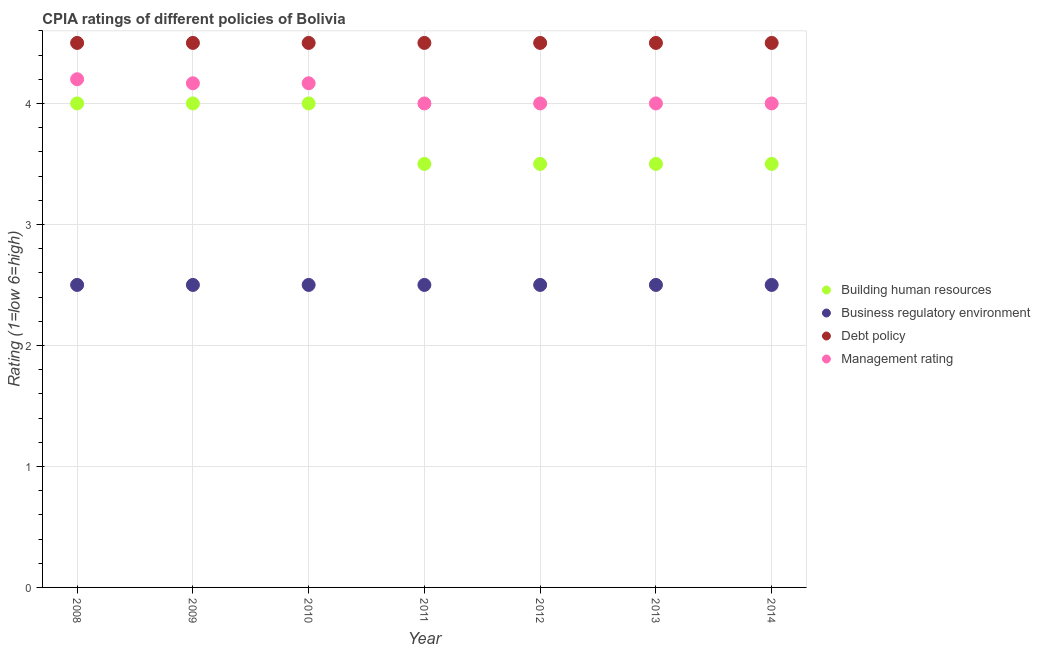Is the number of dotlines equal to the number of legend labels?
Provide a short and direct response. Yes. What is the cpia rating of building human resources in 2009?
Give a very brief answer. 4. In which year was the cpia rating of management maximum?
Your response must be concise. 2008. What is the difference between the cpia rating of building human resources in 2012 and that in 2013?
Make the answer very short. 0. What is the difference between the cpia rating of debt policy in 2013 and the cpia rating of business regulatory environment in 2008?
Your answer should be compact. 2. In the year 2011, what is the difference between the cpia rating of debt policy and cpia rating of business regulatory environment?
Make the answer very short. 2. Is the cpia rating of building human resources in 2010 less than that in 2011?
Provide a succinct answer. No. What is the difference between the highest and the second highest cpia rating of management?
Offer a very short reply. 0.03. Is the sum of the cpia rating of building human resources in 2008 and 2009 greater than the maximum cpia rating of management across all years?
Offer a terse response. Yes. Is it the case that in every year, the sum of the cpia rating of management and cpia rating of building human resources is greater than the sum of cpia rating of business regulatory environment and cpia rating of debt policy?
Your response must be concise. Yes. Does the cpia rating of management monotonically increase over the years?
Give a very brief answer. No. Is the cpia rating of debt policy strictly greater than the cpia rating of business regulatory environment over the years?
Your response must be concise. Yes. Is the cpia rating of building human resources strictly less than the cpia rating of management over the years?
Your answer should be very brief. Yes. How many dotlines are there?
Offer a terse response. 4. Does the graph contain any zero values?
Provide a short and direct response. No. Does the graph contain grids?
Keep it short and to the point. Yes. How are the legend labels stacked?
Keep it short and to the point. Vertical. What is the title of the graph?
Provide a short and direct response. CPIA ratings of different policies of Bolivia. Does "United States" appear as one of the legend labels in the graph?
Your answer should be very brief. No. What is the label or title of the Y-axis?
Your answer should be compact. Rating (1=low 6=high). What is the Rating (1=low 6=high) in Business regulatory environment in 2008?
Your answer should be compact. 2.5. What is the Rating (1=low 6=high) of Business regulatory environment in 2009?
Make the answer very short. 2.5. What is the Rating (1=low 6=high) in Management rating in 2009?
Your answer should be compact. 4.17. What is the Rating (1=low 6=high) of Building human resources in 2010?
Keep it short and to the point. 4. What is the Rating (1=low 6=high) of Business regulatory environment in 2010?
Your response must be concise. 2.5. What is the Rating (1=low 6=high) in Debt policy in 2010?
Your response must be concise. 4.5. What is the Rating (1=low 6=high) in Management rating in 2010?
Your response must be concise. 4.17. What is the Rating (1=low 6=high) in Business regulatory environment in 2011?
Provide a short and direct response. 2.5. What is the Rating (1=low 6=high) of Management rating in 2011?
Offer a very short reply. 4. What is the Rating (1=low 6=high) of Building human resources in 2012?
Ensure brevity in your answer.  3.5. What is the Rating (1=low 6=high) in Debt policy in 2012?
Offer a very short reply. 4.5. What is the Rating (1=low 6=high) in Debt policy in 2013?
Make the answer very short. 4.5. What is the Rating (1=low 6=high) of Management rating in 2013?
Your response must be concise. 4. What is the Rating (1=low 6=high) of Building human resources in 2014?
Your response must be concise. 3.5. What is the Rating (1=low 6=high) in Debt policy in 2014?
Your response must be concise. 4.5. What is the Rating (1=low 6=high) of Management rating in 2014?
Ensure brevity in your answer.  4. Across all years, what is the maximum Rating (1=low 6=high) of Business regulatory environment?
Keep it short and to the point. 2.5. Across all years, what is the maximum Rating (1=low 6=high) in Debt policy?
Provide a succinct answer. 4.5. Across all years, what is the minimum Rating (1=low 6=high) of Building human resources?
Offer a terse response. 3.5. Across all years, what is the minimum Rating (1=low 6=high) in Debt policy?
Offer a terse response. 4.5. Across all years, what is the minimum Rating (1=low 6=high) in Management rating?
Provide a short and direct response. 4. What is the total Rating (1=low 6=high) in Business regulatory environment in the graph?
Your answer should be very brief. 17.5. What is the total Rating (1=low 6=high) of Debt policy in the graph?
Give a very brief answer. 31.5. What is the total Rating (1=low 6=high) in Management rating in the graph?
Your answer should be compact. 28.53. What is the difference between the Rating (1=low 6=high) of Debt policy in 2008 and that in 2009?
Keep it short and to the point. 0. What is the difference between the Rating (1=low 6=high) in Building human resources in 2008 and that in 2010?
Ensure brevity in your answer.  0. What is the difference between the Rating (1=low 6=high) in Business regulatory environment in 2008 and that in 2012?
Give a very brief answer. 0. What is the difference between the Rating (1=low 6=high) of Debt policy in 2008 and that in 2012?
Provide a short and direct response. 0. What is the difference between the Rating (1=low 6=high) of Building human resources in 2008 and that in 2014?
Offer a very short reply. 0.5. What is the difference between the Rating (1=low 6=high) of Business regulatory environment in 2008 and that in 2014?
Offer a very short reply. 0. What is the difference between the Rating (1=low 6=high) of Business regulatory environment in 2009 and that in 2011?
Your answer should be compact. 0. What is the difference between the Rating (1=low 6=high) of Management rating in 2009 and that in 2011?
Your response must be concise. 0.17. What is the difference between the Rating (1=low 6=high) of Debt policy in 2009 and that in 2013?
Provide a succinct answer. 0. What is the difference between the Rating (1=low 6=high) in Management rating in 2009 and that in 2013?
Give a very brief answer. 0.17. What is the difference between the Rating (1=low 6=high) in Building human resources in 2009 and that in 2014?
Provide a short and direct response. 0.5. What is the difference between the Rating (1=low 6=high) in Building human resources in 2010 and that in 2011?
Your answer should be compact. 0.5. What is the difference between the Rating (1=low 6=high) of Business regulatory environment in 2010 and that in 2012?
Your answer should be compact. 0. What is the difference between the Rating (1=low 6=high) of Debt policy in 2010 and that in 2012?
Ensure brevity in your answer.  0. What is the difference between the Rating (1=low 6=high) in Management rating in 2010 and that in 2012?
Your answer should be very brief. 0.17. What is the difference between the Rating (1=low 6=high) of Building human resources in 2010 and that in 2013?
Your answer should be very brief. 0.5. What is the difference between the Rating (1=low 6=high) in Business regulatory environment in 2010 and that in 2013?
Provide a succinct answer. 0. What is the difference between the Rating (1=low 6=high) of Management rating in 2010 and that in 2013?
Provide a short and direct response. 0.17. What is the difference between the Rating (1=low 6=high) of Building human resources in 2010 and that in 2014?
Offer a very short reply. 0.5. What is the difference between the Rating (1=low 6=high) in Debt policy in 2010 and that in 2014?
Your answer should be compact. 0. What is the difference between the Rating (1=low 6=high) in Management rating in 2010 and that in 2014?
Keep it short and to the point. 0.17. What is the difference between the Rating (1=low 6=high) of Building human resources in 2011 and that in 2012?
Your answer should be very brief. 0. What is the difference between the Rating (1=low 6=high) in Business regulatory environment in 2011 and that in 2012?
Give a very brief answer. 0. What is the difference between the Rating (1=low 6=high) in Debt policy in 2011 and that in 2012?
Your response must be concise. 0. What is the difference between the Rating (1=low 6=high) in Management rating in 2011 and that in 2012?
Your answer should be very brief. 0. What is the difference between the Rating (1=low 6=high) in Building human resources in 2011 and that in 2013?
Your answer should be compact. 0. What is the difference between the Rating (1=low 6=high) of Business regulatory environment in 2011 and that in 2013?
Keep it short and to the point. 0. What is the difference between the Rating (1=low 6=high) of Debt policy in 2011 and that in 2013?
Keep it short and to the point. 0. What is the difference between the Rating (1=low 6=high) of Management rating in 2011 and that in 2013?
Ensure brevity in your answer.  0. What is the difference between the Rating (1=low 6=high) in Business regulatory environment in 2011 and that in 2014?
Offer a very short reply. 0. What is the difference between the Rating (1=low 6=high) in Building human resources in 2012 and that in 2013?
Give a very brief answer. 0. What is the difference between the Rating (1=low 6=high) in Management rating in 2012 and that in 2013?
Provide a short and direct response. 0. What is the difference between the Rating (1=low 6=high) in Business regulatory environment in 2012 and that in 2014?
Offer a terse response. 0. What is the difference between the Rating (1=low 6=high) of Debt policy in 2012 and that in 2014?
Ensure brevity in your answer.  0. What is the difference between the Rating (1=low 6=high) of Management rating in 2012 and that in 2014?
Make the answer very short. 0. What is the difference between the Rating (1=low 6=high) of Building human resources in 2008 and the Rating (1=low 6=high) of Business regulatory environment in 2009?
Your response must be concise. 1.5. What is the difference between the Rating (1=low 6=high) in Building human resources in 2008 and the Rating (1=low 6=high) in Debt policy in 2009?
Provide a short and direct response. -0.5. What is the difference between the Rating (1=low 6=high) in Building human resources in 2008 and the Rating (1=low 6=high) in Management rating in 2009?
Offer a very short reply. -0.17. What is the difference between the Rating (1=low 6=high) in Business regulatory environment in 2008 and the Rating (1=low 6=high) in Management rating in 2009?
Give a very brief answer. -1.67. What is the difference between the Rating (1=low 6=high) in Building human resources in 2008 and the Rating (1=low 6=high) in Business regulatory environment in 2010?
Offer a terse response. 1.5. What is the difference between the Rating (1=low 6=high) of Building human resources in 2008 and the Rating (1=low 6=high) of Debt policy in 2010?
Your answer should be very brief. -0.5. What is the difference between the Rating (1=low 6=high) in Business regulatory environment in 2008 and the Rating (1=low 6=high) in Management rating in 2010?
Give a very brief answer. -1.67. What is the difference between the Rating (1=low 6=high) of Debt policy in 2008 and the Rating (1=low 6=high) of Management rating in 2011?
Provide a succinct answer. 0.5. What is the difference between the Rating (1=low 6=high) in Building human resources in 2008 and the Rating (1=low 6=high) in Debt policy in 2012?
Offer a very short reply. -0.5. What is the difference between the Rating (1=low 6=high) in Building human resources in 2008 and the Rating (1=low 6=high) in Management rating in 2012?
Your answer should be very brief. 0. What is the difference between the Rating (1=low 6=high) in Business regulatory environment in 2008 and the Rating (1=low 6=high) in Management rating in 2012?
Offer a terse response. -1.5. What is the difference between the Rating (1=low 6=high) of Debt policy in 2008 and the Rating (1=low 6=high) of Management rating in 2012?
Offer a terse response. 0.5. What is the difference between the Rating (1=low 6=high) of Building human resources in 2008 and the Rating (1=low 6=high) of Business regulatory environment in 2013?
Provide a succinct answer. 1.5. What is the difference between the Rating (1=low 6=high) of Building human resources in 2008 and the Rating (1=low 6=high) of Debt policy in 2013?
Offer a very short reply. -0.5. What is the difference between the Rating (1=low 6=high) in Building human resources in 2008 and the Rating (1=low 6=high) in Management rating in 2013?
Keep it short and to the point. 0. What is the difference between the Rating (1=low 6=high) in Business regulatory environment in 2008 and the Rating (1=low 6=high) in Debt policy in 2013?
Provide a succinct answer. -2. What is the difference between the Rating (1=low 6=high) of Business regulatory environment in 2008 and the Rating (1=low 6=high) of Management rating in 2013?
Your answer should be very brief. -1.5. What is the difference between the Rating (1=low 6=high) of Debt policy in 2008 and the Rating (1=low 6=high) of Management rating in 2013?
Make the answer very short. 0.5. What is the difference between the Rating (1=low 6=high) of Building human resources in 2008 and the Rating (1=low 6=high) of Business regulatory environment in 2014?
Your answer should be very brief. 1.5. What is the difference between the Rating (1=low 6=high) in Building human resources in 2008 and the Rating (1=low 6=high) in Management rating in 2014?
Make the answer very short. 0. What is the difference between the Rating (1=low 6=high) in Business regulatory environment in 2008 and the Rating (1=low 6=high) in Debt policy in 2014?
Your response must be concise. -2. What is the difference between the Rating (1=low 6=high) of Debt policy in 2008 and the Rating (1=low 6=high) of Management rating in 2014?
Your answer should be very brief. 0.5. What is the difference between the Rating (1=low 6=high) in Building human resources in 2009 and the Rating (1=low 6=high) in Business regulatory environment in 2010?
Offer a very short reply. 1.5. What is the difference between the Rating (1=low 6=high) of Building human resources in 2009 and the Rating (1=low 6=high) of Management rating in 2010?
Make the answer very short. -0.17. What is the difference between the Rating (1=low 6=high) of Business regulatory environment in 2009 and the Rating (1=low 6=high) of Management rating in 2010?
Make the answer very short. -1.67. What is the difference between the Rating (1=low 6=high) in Debt policy in 2009 and the Rating (1=low 6=high) in Management rating in 2010?
Offer a terse response. 0.33. What is the difference between the Rating (1=low 6=high) of Building human resources in 2009 and the Rating (1=low 6=high) of Debt policy in 2011?
Make the answer very short. -0.5. What is the difference between the Rating (1=low 6=high) of Business regulatory environment in 2009 and the Rating (1=low 6=high) of Debt policy in 2011?
Give a very brief answer. -2. What is the difference between the Rating (1=low 6=high) of Building human resources in 2009 and the Rating (1=low 6=high) of Business regulatory environment in 2012?
Offer a very short reply. 1.5. What is the difference between the Rating (1=low 6=high) in Building human resources in 2009 and the Rating (1=low 6=high) in Management rating in 2012?
Your answer should be very brief. 0. What is the difference between the Rating (1=low 6=high) in Business regulatory environment in 2009 and the Rating (1=low 6=high) in Management rating in 2012?
Give a very brief answer. -1.5. What is the difference between the Rating (1=low 6=high) of Business regulatory environment in 2009 and the Rating (1=low 6=high) of Debt policy in 2013?
Your answer should be very brief. -2. What is the difference between the Rating (1=low 6=high) in Business regulatory environment in 2009 and the Rating (1=low 6=high) in Management rating in 2013?
Your response must be concise. -1.5. What is the difference between the Rating (1=low 6=high) in Debt policy in 2009 and the Rating (1=low 6=high) in Management rating in 2013?
Provide a succinct answer. 0.5. What is the difference between the Rating (1=low 6=high) of Building human resources in 2009 and the Rating (1=low 6=high) of Management rating in 2014?
Your answer should be compact. 0. What is the difference between the Rating (1=low 6=high) in Business regulatory environment in 2009 and the Rating (1=low 6=high) in Debt policy in 2014?
Give a very brief answer. -2. What is the difference between the Rating (1=low 6=high) of Building human resources in 2010 and the Rating (1=low 6=high) of Debt policy in 2011?
Your answer should be very brief. -0.5. What is the difference between the Rating (1=low 6=high) of Building human resources in 2010 and the Rating (1=low 6=high) of Management rating in 2011?
Give a very brief answer. 0. What is the difference between the Rating (1=low 6=high) of Business regulatory environment in 2010 and the Rating (1=low 6=high) of Debt policy in 2011?
Your answer should be compact. -2. What is the difference between the Rating (1=low 6=high) in Business regulatory environment in 2010 and the Rating (1=low 6=high) in Management rating in 2011?
Give a very brief answer. -1.5. What is the difference between the Rating (1=low 6=high) in Building human resources in 2010 and the Rating (1=low 6=high) in Business regulatory environment in 2012?
Make the answer very short. 1.5. What is the difference between the Rating (1=low 6=high) in Building human resources in 2010 and the Rating (1=low 6=high) in Management rating in 2012?
Offer a very short reply. 0. What is the difference between the Rating (1=low 6=high) in Business regulatory environment in 2010 and the Rating (1=low 6=high) in Debt policy in 2012?
Keep it short and to the point. -2. What is the difference between the Rating (1=low 6=high) of Debt policy in 2010 and the Rating (1=low 6=high) of Management rating in 2012?
Make the answer very short. 0.5. What is the difference between the Rating (1=low 6=high) of Building human resources in 2010 and the Rating (1=low 6=high) of Debt policy in 2013?
Your answer should be compact. -0.5. What is the difference between the Rating (1=low 6=high) of Building human resources in 2010 and the Rating (1=low 6=high) of Management rating in 2013?
Provide a short and direct response. 0. What is the difference between the Rating (1=low 6=high) of Building human resources in 2010 and the Rating (1=low 6=high) of Business regulatory environment in 2014?
Make the answer very short. 1.5. What is the difference between the Rating (1=low 6=high) in Building human resources in 2011 and the Rating (1=low 6=high) in Business regulatory environment in 2012?
Keep it short and to the point. 1. What is the difference between the Rating (1=low 6=high) in Building human resources in 2011 and the Rating (1=low 6=high) in Debt policy in 2012?
Your response must be concise. -1. What is the difference between the Rating (1=low 6=high) in Business regulatory environment in 2011 and the Rating (1=low 6=high) in Debt policy in 2012?
Provide a succinct answer. -2. What is the difference between the Rating (1=low 6=high) of Building human resources in 2011 and the Rating (1=low 6=high) of Management rating in 2013?
Provide a short and direct response. -0.5. What is the difference between the Rating (1=low 6=high) in Business regulatory environment in 2011 and the Rating (1=low 6=high) in Debt policy in 2013?
Ensure brevity in your answer.  -2. What is the difference between the Rating (1=low 6=high) of Business regulatory environment in 2011 and the Rating (1=low 6=high) of Management rating in 2013?
Offer a terse response. -1.5. What is the difference between the Rating (1=low 6=high) of Debt policy in 2011 and the Rating (1=low 6=high) of Management rating in 2013?
Keep it short and to the point. 0.5. What is the difference between the Rating (1=low 6=high) of Building human resources in 2011 and the Rating (1=low 6=high) of Business regulatory environment in 2014?
Your response must be concise. 1. What is the difference between the Rating (1=low 6=high) of Building human resources in 2011 and the Rating (1=low 6=high) of Management rating in 2014?
Offer a very short reply. -0.5. What is the difference between the Rating (1=low 6=high) in Business regulatory environment in 2011 and the Rating (1=low 6=high) in Debt policy in 2014?
Give a very brief answer. -2. What is the difference between the Rating (1=low 6=high) of Building human resources in 2012 and the Rating (1=low 6=high) of Business regulatory environment in 2013?
Provide a succinct answer. 1. What is the difference between the Rating (1=low 6=high) of Building human resources in 2012 and the Rating (1=low 6=high) of Debt policy in 2013?
Ensure brevity in your answer.  -1. What is the difference between the Rating (1=low 6=high) of Building human resources in 2012 and the Rating (1=low 6=high) of Management rating in 2013?
Provide a short and direct response. -0.5. What is the difference between the Rating (1=low 6=high) of Business regulatory environment in 2012 and the Rating (1=low 6=high) of Debt policy in 2013?
Your answer should be very brief. -2. What is the difference between the Rating (1=low 6=high) in Business regulatory environment in 2012 and the Rating (1=low 6=high) in Management rating in 2013?
Keep it short and to the point. -1.5. What is the difference between the Rating (1=low 6=high) in Debt policy in 2012 and the Rating (1=low 6=high) in Management rating in 2013?
Your answer should be very brief. 0.5. What is the difference between the Rating (1=low 6=high) in Building human resources in 2012 and the Rating (1=low 6=high) in Business regulatory environment in 2014?
Make the answer very short. 1. What is the difference between the Rating (1=low 6=high) of Business regulatory environment in 2012 and the Rating (1=low 6=high) of Management rating in 2014?
Provide a short and direct response. -1.5. What is the difference between the Rating (1=low 6=high) in Debt policy in 2012 and the Rating (1=low 6=high) in Management rating in 2014?
Provide a short and direct response. 0.5. What is the difference between the Rating (1=low 6=high) of Building human resources in 2013 and the Rating (1=low 6=high) of Management rating in 2014?
Your response must be concise. -0.5. What is the difference between the Rating (1=low 6=high) in Debt policy in 2013 and the Rating (1=low 6=high) in Management rating in 2014?
Make the answer very short. 0.5. What is the average Rating (1=low 6=high) in Building human resources per year?
Give a very brief answer. 3.71. What is the average Rating (1=low 6=high) of Debt policy per year?
Make the answer very short. 4.5. What is the average Rating (1=low 6=high) in Management rating per year?
Offer a terse response. 4.08. In the year 2008, what is the difference between the Rating (1=low 6=high) of Building human resources and Rating (1=low 6=high) of Management rating?
Your response must be concise. -0.2. In the year 2008, what is the difference between the Rating (1=low 6=high) of Business regulatory environment and Rating (1=low 6=high) of Debt policy?
Provide a short and direct response. -2. In the year 2008, what is the difference between the Rating (1=low 6=high) of Business regulatory environment and Rating (1=low 6=high) of Management rating?
Make the answer very short. -1.7. In the year 2009, what is the difference between the Rating (1=low 6=high) of Building human resources and Rating (1=low 6=high) of Business regulatory environment?
Your answer should be very brief. 1.5. In the year 2009, what is the difference between the Rating (1=low 6=high) of Building human resources and Rating (1=low 6=high) of Management rating?
Make the answer very short. -0.17. In the year 2009, what is the difference between the Rating (1=low 6=high) of Business regulatory environment and Rating (1=low 6=high) of Debt policy?
Provide a short and direct response. -2. In the year 2009, what is the difference between the Rating (1=low 6=high) of Business regulatory environment and Rating (1=low 6=high) of Management rating?
Your response must be concise. -1.67. In the year 2010, what is the difference between the Rating (1=low 6=high) of Building human resources and Rating (1=low 6=high) of Business regulatory environment?
Give a very brief answer. 1.5. In the year 2010, what is the difference between the Rating (1=low 6=high) in Building human resources and Rating (1=low 6=high) in Debt policy?
Your response must be concise. -0.5. In the year 2010, what is the difference between the Rating (1=low 6=high) in Building human resources and Rating (1=low 6=high) in Management rating?
Your answer should be compact. -0.17. In the year 2010, what is the difference between the Rating (1=low 6=high) of Business regulatory environment and Rating (1=low 6=high) of Management rating?
Provide a short and direct response. -1.67. In the year 2010, what is the difference between the Rating (1=low 6=high) in Debt policy and Rating (1=low 6=high) in Management rating?
Your answer should be compact. 0.33. In the year 2011, what is the difference between the Rating (1=low 6=high) in Building human resources and Rating (1=low 6=high) in Debt policy?
Provide a succinct answer. -1. In the year 2011, what is the difference between the Rating (1=low 6=high) of Building human resources and Rating (1=low 6=high) of Management rating?
Offer a very short reply. -0.5. In the year 2011, what is the difference between the Rating (1=low 6=high) in Business regulatory environment and Rating (1=low 6=high) in Debt policy?
Provide a succinct answer. -2. In the year 2011, what is the difference between the Rating (1=low 6=high) of Business regulatory environment and Rating (1=low 6=high) of Management rating?
Offer a very short reply. -1.5. In the year 2011, what is the difference between the Rating (1=low 6=high) of Debt policy and Rating (1=low 6=high) of Management rating?
Offer a terse response. 0.5. In the year 2012, what is the difference between the Rating (1=low 6=high) of Building human resources and Rating (1=low 6=high) of Business regulatory environment?
Offer a very short reply. 1. In the year 2012, what is the difference between the Rating (1=low 6=high) of Building human resources and Rating (1=low 6=high) of Debt policy?
Make the answer very short. -1. In the year 2012, what is the difference between the Rating (1=low 6=high) of Building human resources and Rating (1=low 6=high) of Management rating?
Your response must be concise. -0.5. In the year 2012, what is the difference between the Rating (1=low 6=high) of Business regulatory environment and Rating (1=low 6=high) of Debt policy?
Give a very brief answer. -2. In the year 2013, what is the difference between the Rating (1=low 6=high) in Building human resources and Rating (1=low 6=high) in Business regulatory environment?
Ensure brevity in your answer.  1. In the year 2013, what is the difference between the Rating (1=low 6=high) of Building human resources and Rating (1=low 6=high) of Management rating?
Offer a terse response. -0.5. In the year 2013, what is the difference between the Rating (1=low 6=high) in Business regulatory environment and Rating (1=low 6=high) in Debt policy?
Your answer should be very brief. -2. In the year 2013, what is the difference between the Rating (1=low 6=high) in Business regulatory environment and Rating (1=low 6=high) in Management rating?
Keep it short and to the point. -1.5. In the year 2014, what is the difference between the Rating (1=low 6=high) of Building human resources and Rating (1=low 6=high) of Business regulatory environment?
Your answer should be very brief. 1. In the year 2014, what is the difference between the Rating (1=low 6=high) in Building human resources and Rating (1=low 6=high) in Debt policy?
Make the answer very short. -1. In the year 2014, what is the difference between the Rating (1=low 6=high) in Business regulatory environment and Rating (1=low 6=high) in Debt policy?
Provide a short and direct response. -2. In the year 2014, what is the difference between the Rating (1=low 6=high) in Business regulatory environment and Rating (1=low 6=high) in Management rating?
Make the answer very short. -1.5. In the year 2014, what is the difference between the Rating (1=low 6=high) of Debt policy and Rating (1=low 6=high) of Management rating?
Ensure brevity in your answer.  0.5. What is the ratio of the Rating (1=low 6=high) of Building human resources in 2008 to that in 2009?
Your response must be concise. 1. What is the ratio of the Rating (1=low 6=high) of Business regulatory environment in 2008 to that in 2009?
Make the answer very short. 1. What is the ratio of the Rating (1=low 6=high) of Building human resources in 2008 to that in 2010?
Keep it short and to the point. 1. What is the ratio of the Rating (1=low 6=high) of Debt policy in 2008 to that in 2010?
Give a very brief answer. 1. What is the ratio of the Rating (1=low 6=high) in Management rating in 2008 to that in 2010?
Your answer should be compact. 1.01. What is the ratio of the Rating (1=low 6=high) of Building human resources in 2008 to that in 2011?
Your answer should be very brief. 1.14. What is the ratio of the Rating (1=low 6=high) of Business regulatory environment in 2008 to that in 2011?
Keep it short and to the point. 1. What is the ratio of the Rating (1=low 6=high) in Debt policy in 2008 to that in 2011?
Keep it short and to the point. 1. What is the ratio of the Rating (1=low 6=high) in Building human resources in 2008 to that in 2012?
Your response must be concise. 1.14. What is the ratio of the Rating (1=low 6=high) of Business regulatory environment in 2008 to that in 2012?
Give a very brief answer. 1. What is the ratio of the Rating (1=low 6=high) of Debt policy in 2008 to that in 2012?
Your response must be concise. 1. What is the ratio of the Rating (1=low 6=high) in Management rating in 2008 to that in 2012?
Your answer should be very brief. 1.05. What is the ratio of the Rating (1=low 6=high) of Building human resources in 2008 to that in 2013?
Your answer should be very brief. 1.14. What is the ratio of the Rating (1=low 6=high) of Business regulatory environment in 2008 to that in 2013?
Give a very brief answer. 1. What is the ratio of the Rating (1=low 6=high) of Building human resources in 2008 to that in 2014?
Ensure brevity in your answer.  1.14. What is the ratio of the Rating (1=low 6=high) in Business regulatory environment in 2008 to that in 2014?
Offer a terse response. 1. What is the ratio of the Rating (1=low 6=high) in Debt policy in 2008 to that in 2014?
Keep it short and to the point. 1. What is the ratio of the Rating (1=low 6=high) of Management rating in 2008 to that in 2014?
Give a very brief answer. 1.05. What is the ratio of the Rating (1=low 6=high) of Building human resources in 2009 to that in 2010?
Give a very brief answer. 1. What is the ratio of the Rating (1=low 6=high) of Business regulatory environment in 2009 to that in 2010?
Ensure brevity in your answer.  1. What is the ratio of the Rating (1=low 6=high) of Debt policy in 2009 to that in 2010?
Your response must be concise. 1. What is the ratio of the Rating (1=low 6=high) of Building human resources in 2009 to that in 2011?
Keep it short and to the point. 1.14. What is the ratio of the Rating (1=low 6=high) of Management rating in 2009 to that in 2011?
Provide a short and direct response. 1.04. What is the ratio of the Rating (1=low 6=high) of Debt policy in 2009 to that in 2012?
Ensure brevity in your answer.  1. What is the ratio of the Rating (1=low 6=high) of Management rating in 2009 to that in 2012?
Offer a very short reply. 1.04. What is the ratio of the Rating (1=low 6=high) in Debt policy in 2009 to that in 2013?
Provide a short and direct response. 1. What is the ratio of the Rating (1=low 6=high) of Management rating in 2009 to that in 2013?
Provide a short and direct response. 1.04. What is the ratio of the Rating (1=low 6=high) of Building human resources in 2009 to that in 2014?
Keep it short and to the point. 1.14. What is the ratio of the Rating (1=low 6=high) in Business regulatory environment in 2009 to that in 2014?
Provide a short and direct response. 1. What is the ratio of the Rating (1=low 6=high) of Debt policy in 2009 to that in 2014?
Your answer should be compact. 1. What is the ratio of the Rating (1=low 6=high) of Management rating in 2009 to that in 2014?
Make the answer very short. 1.04. What is the ratio of the Rating (1=low 6=high) in Business regulatory environment in 2010 to that in 2011?
Your answer should be very brief. 1. What is the ratio of the Rating (1=low 6=high) in Management rating in 2010 to that in 2011?
Provide a short and direct response. 1.04. What is the ratio of the Rating (1=low 6=high) in Building human resources in 2010 to that in 2012?
Offer a very short reply. 1.14. What is the ratio of the Rating (1=low 6=high) in Business regulatory environment in 2010 to that in 2012?
Your response must be concise. 1. What is the ratio of the Rating (1=low 6=high) in Debt policy in 2010 to that in 2012?
Keep it short and to the point. 1. What is the ratio of the Rating (1=low 6=high) in Management rating in 2010 to that in 2012?
Provide a short and direct response. 1.04. What is the ratio of the Rating (1=low 6=high) of Building human resources in 2010 to that in 2013?
Give a very brief answer. 1.14. What is the ratio of the Rating (1=low 6=high) of Business regulatory environment in 2010 to that in 2013?
Give a very brief answer. 1. What is the ratio of the Rating (1=low 6=high) of Management rating in 2010 to that in 2013?
Make the answer very short. 1.04. What is the ratio of the Rating (1=low 6=high) of Business regulatory environment in 2010 to that in 2014?
Your answer should be very brief. 1. What is the ratio of the Rating (1=low 6=high) in Debt policy in 2010 to that in 2014?
Offer a very short reply. 1. What is the ratio of the Rating (1=low 6=high) in Management rating in 2010 to that in 2014?
Ensure brevity in your answer.  1.04. What is the ratio of the Rating (1=low 6=high) of Building human resources in 2011 to that in 2012?
Your answer should be very brief. 1. What is the ratio of the Rating (1=low 6=high) in Business regulatory environment in 2011 to that in 2012?
Keep it short and to the point. 1. What is the ratio of the Rating (1=low 6=high) in Building human resources in 2011 to that in 2013?
Offer a very short reply. 1. What is the ratio of the Rating (1=low 6=high) of Debt policy in 2011 to that in 2013?
Your answer should be very brief. 1. What is the ratio of the Rating (1=low 6=high) of Management rating in 2011 to that in 2013?
Keep it short and to the point. 1. What is the ratio of the Rating (1=low 6=high) of Debt policy in 2011 to that in 2014?
Provide a short and direct response. 1. What is the ratio of the Rating (1=low 6=high) in Debt policy in 2012 to that in 2013?
Provide a succinct answer. 1. What is the ratio of the Rating (1=low 6=high) of Management rating in 2012 to that in 2013?
Offer a terse response. 1. What is the ratio of the Rating (1=low 6=high) of Business regulatory environment in 2012 to that in 2014?
Your response must be concise. 1. What is the ratio of the Rating (1=low 6=high) of Debt policy in 2012 to that in 2014?
Keep it short and to the point. 1. What is the ratio of the Rating (1=low 6=high) of Management rating in 2012 to that in 2014?
Give a very brief answer. 1. What is the ratio of the Rating (1=low 6=high) in Building human resources in 2013 to that in 2014?
Your response must be concise. 1. What is the ratio of the Rating (1=low 6=high) of Debt policy in 2013 to that in 2014?
Provide a short and direct response. 1. What is the ratio of the Rating (1=low 6=high) in Management rating in 2013 to that in 2014?
Offer a very short reply. 1. What is the difference between the highest and the second highest Rating (1=low 6=high) in Business regulatory environment?
Offer a very short reply. 0. What is the difference between the highest and the lowest Rating (1=low 6=high) of Building human resources?
Offer a very short reply. 0.5. What is the difference between the highest and the lowest Rating (1=low 6=high) of Business regulatory environment?
Keep it short and to the point. 0. 